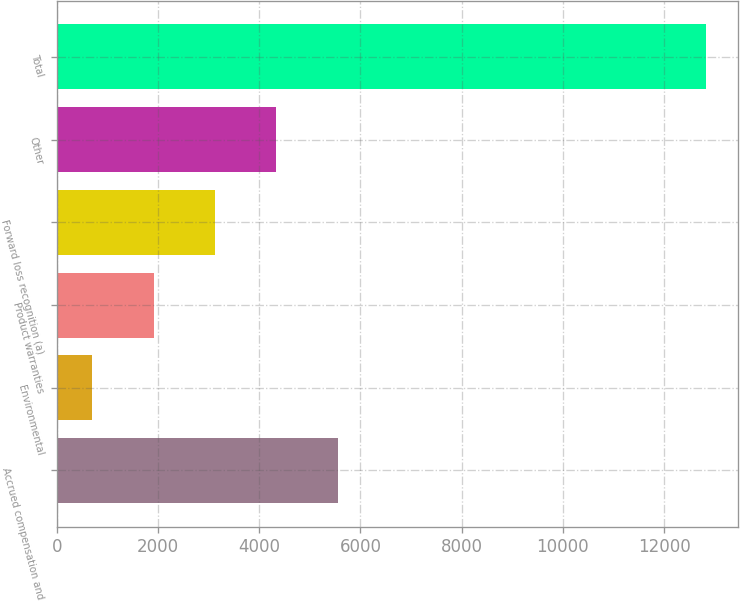Convert chart. <chart><loc_0><loc_0><loc_500><loc_500><bar_chart><fcel>Accrued compensation and<fcel>Environmental<fcel>Product warranties<fcel>Forward loss recognition (a)<fcel>Other<fcel>Total<nl><fcel>5552.4<fcel>706<fcel>1917.6<fcel>3129.2<fcel>4340.8<fcel>12822<nl></chart> 